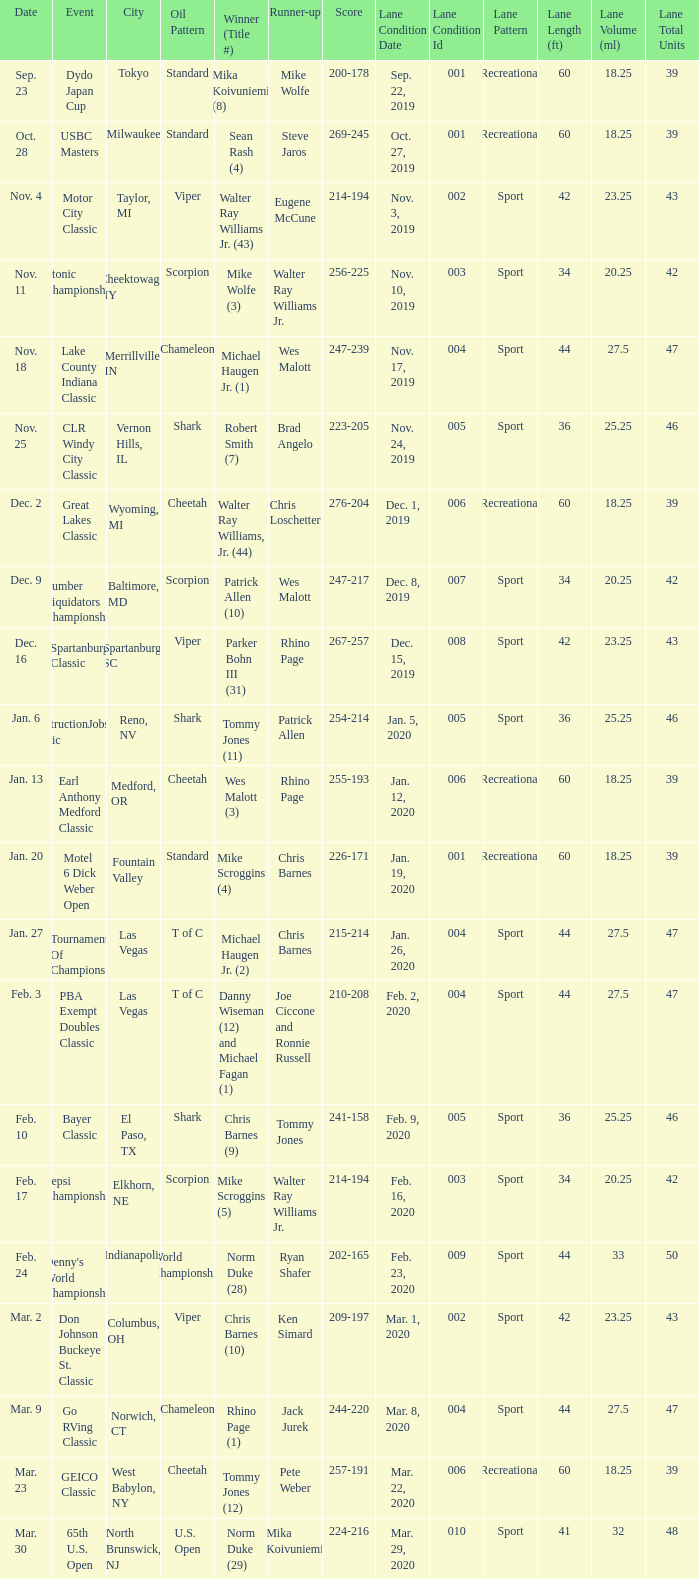Name the Date which has a Oil Pattern of chameleon, and a Event of lake county indiana classic? Nov. 18. 